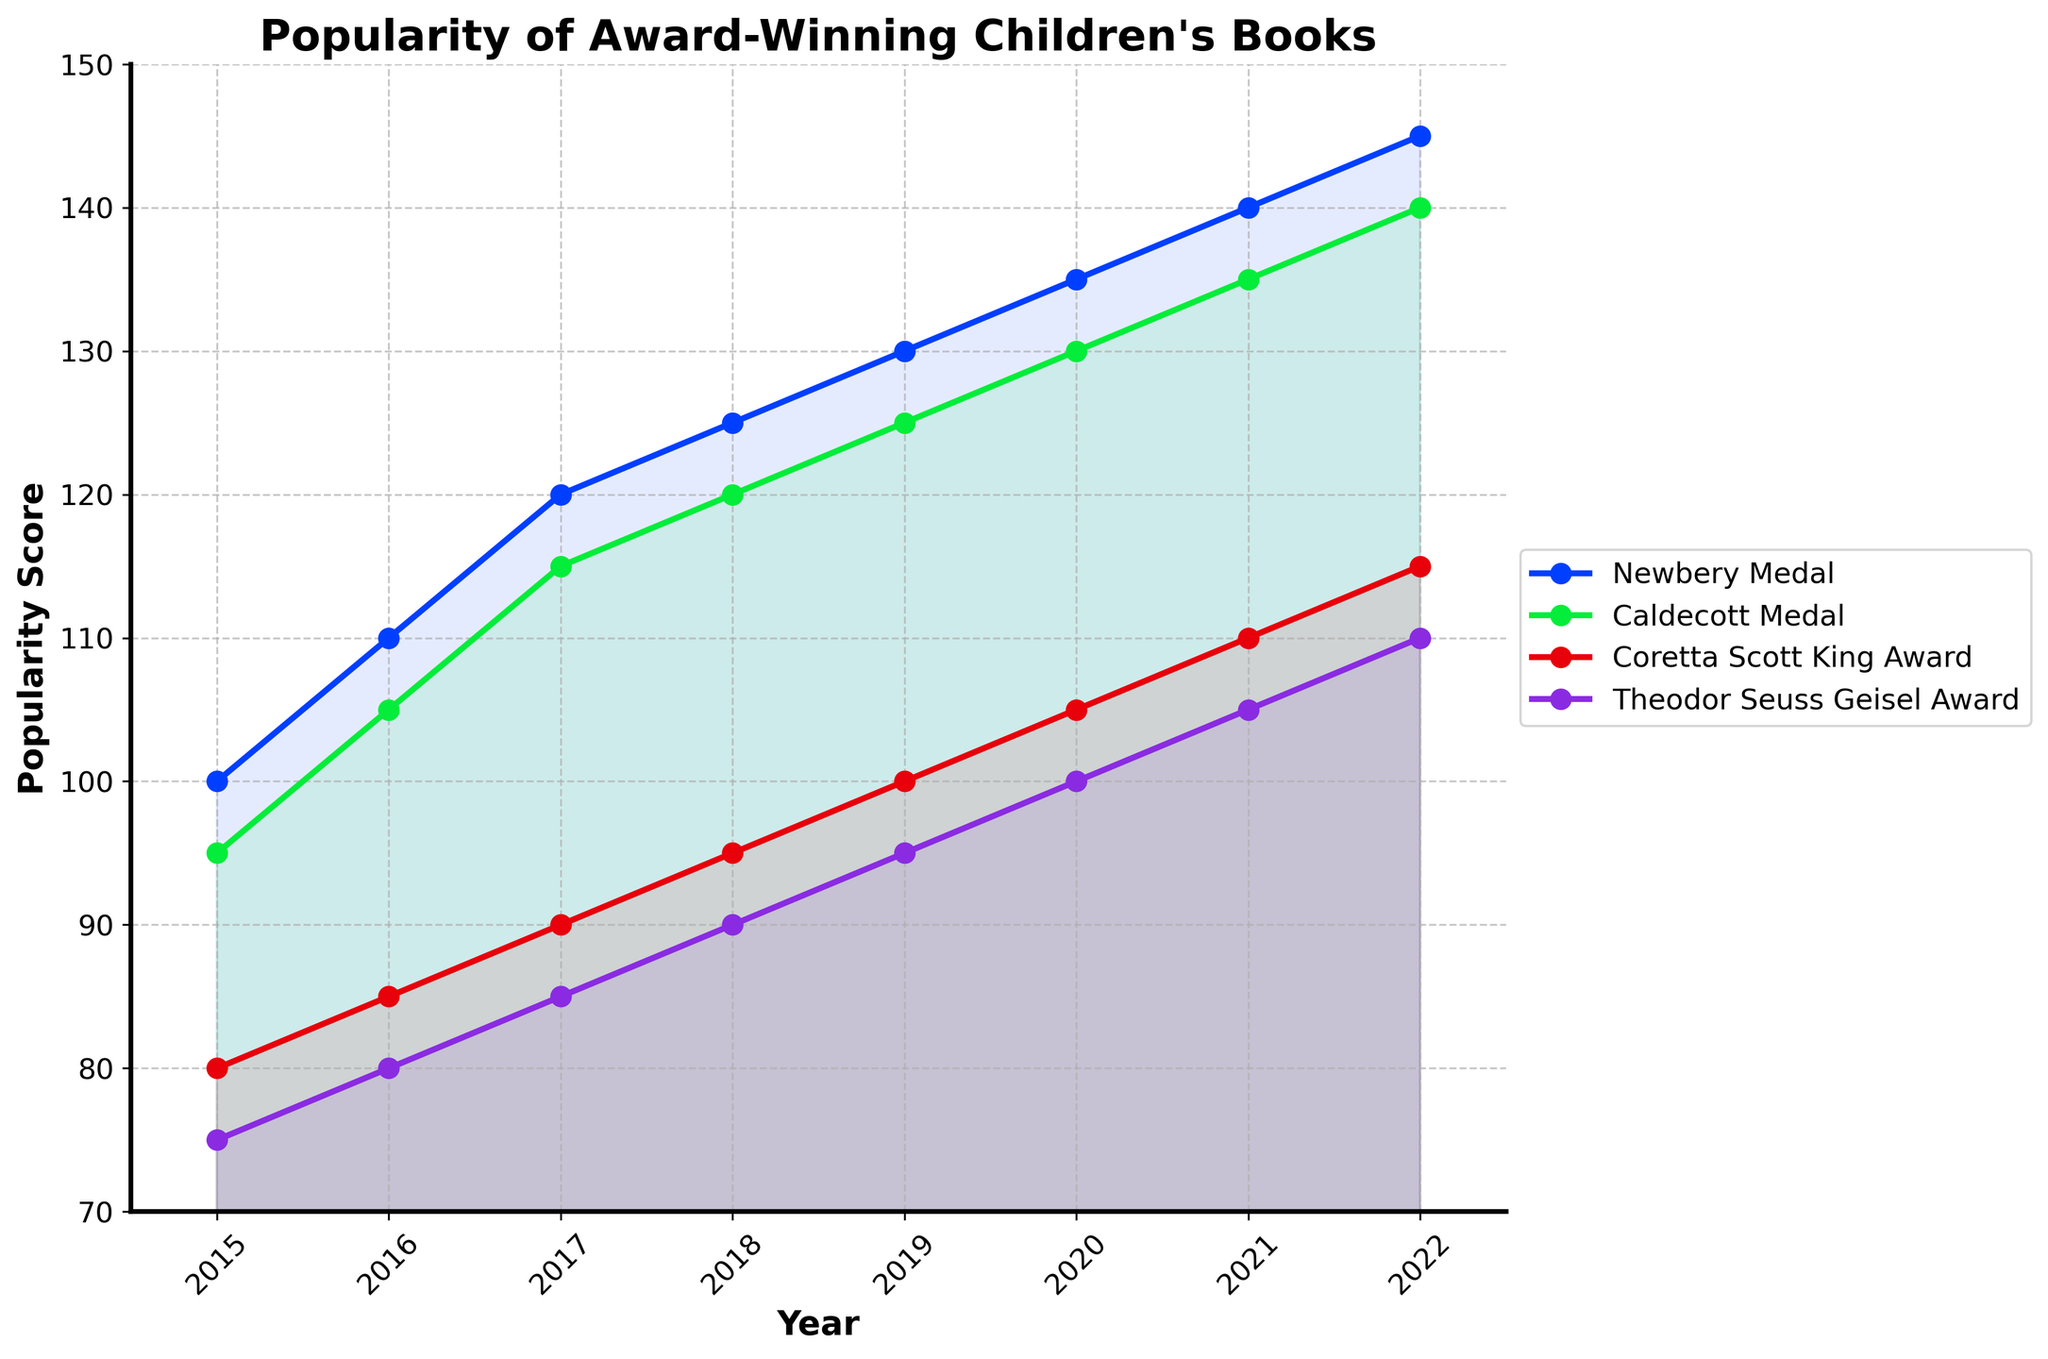What is the trend in the popularity score of the Newbery Medal-winning children's books from 2015 to 2022? The popularity score of the Newbery Medal-winning children's books shows a consistent increase from 100 in 2015 to 145 in 2022.
Answer: Increasing Which award had the lowest popularity score in 2015? Look at the popularity scores for all four awards in 2015. The Theodor Seuss Geisel Award had the lowest score at 75.
Answer: Theodor Seuss Geisel Award By how much did the popularity score of the Caldecott Medal-winning books increase from 2015 to 2022? Subtract the popularity score of 2015 (95) from the score in 2022 (140). The increase is 140 - 95 = 45.
Answer: 45 Which award saw the largest change in popularity score between 2015 and 2022? Calculate the change for each award and compare. The Newbery Medal increased by 45, the Caldecott Medal by 45, the Coretta Scott King Award by 35, and the Theodor Seuss Geisel Award by 35. The Newbery Medal and Caldecott Medal both had the largest increase of 45.
Answer: Newbery Medal and Caldecott Medal In which year were the popularity scores of all awards exactly on a 5-point increment? Assess the data yearly. In 2018, all awards had scores that were multiples of 5 (Newbery: 125, Caldecott: 120, Coretta Scott King: 95, Theodor Seuss Geisel: 90).
Answer: 2018 What is the average popularity score of the Coretta Scott King Award over the period 2015 to 2022? Sum the scores for each year (80 + 85 + 90 + 95 + 100 + 105 + 110 + 115 = 780). Divide by the number of years (8). The average is 780 / 8 = 97.5.
Answer: 97.5 In which year did the Newbery Medal-winning books first surpass a popularity score of 130? Identify the year in the data where the Newbery Medal score first exceeds 130. It happened in 2019 when the score was 130, and then 135 in 2020.
Answer: 2019 Which award's popularity score increased the least between 2019 and 2022? Compare the changes in popularity score from 2019 to 2022 for each award. Coretta Scott King Award increased from 100 to 115, a difference of 15, which is the least increase.
Answer: Coretta Scott King Award What is the difference in popularity score between the Newbery Medal and the Coretta Scott King Award in 2022? Subtract the Coretta Scott King Award's 2022 score (115) from the Newbery Medal's 2022 score (145). The difference is 145 - 115 = 30.
Answer: 30 